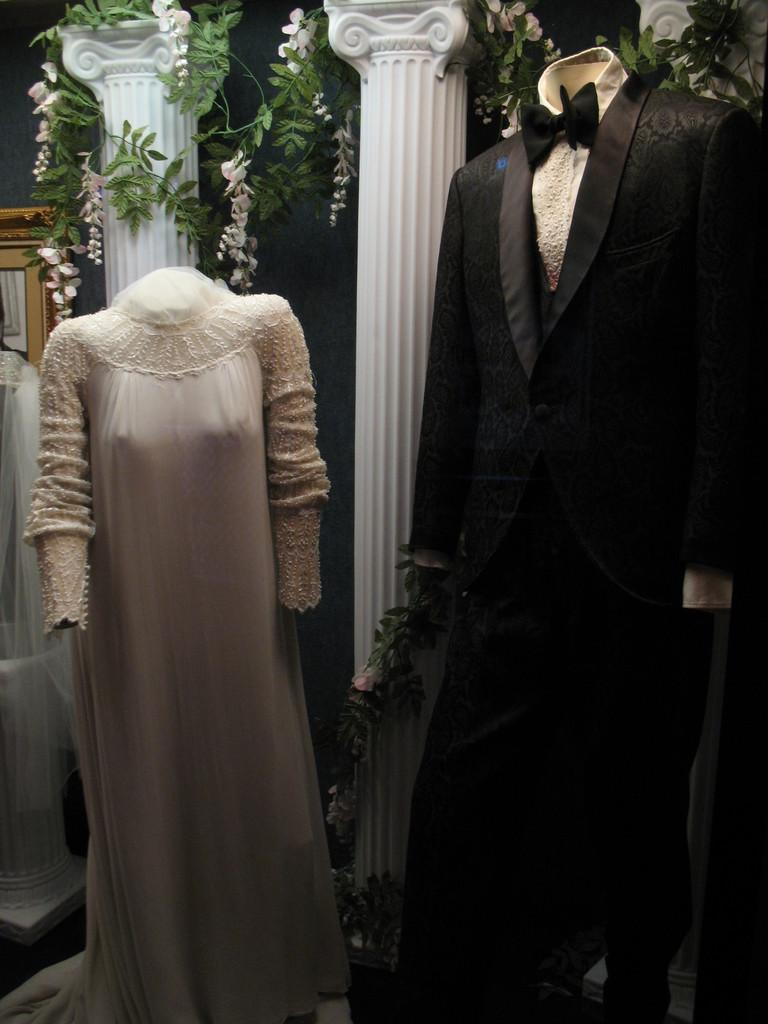What can be seen in the foreground of the picture? There are mannequins and dresses in the foreground of the picture. What is located at the top of the image? There are flowers, leaves, and pillars at the top of the image. Can you describe the dress on the left side of the image? There is a dress on the left side of the image. What else is present on the left side of the image? There is a frame on the left side of the image. How many bears are visible in the image? There are no bears present in the image. What color are the toes of the mannequins in the image? There are no visible toes on the mannequins in the image. 